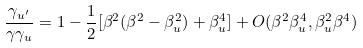Convert formula to latex. <formula><loc_0><loc_0><loc_500><loc_500>\frac { \gamma _ { u ^ { \prime } } } { \gamma \gamma _ { u } } = 1 - \frac { 1 } { 2 } [ \beta ^ { 2 } ( \beta ^ { 2 } - \beta _ { u } ^ { 2 } ) + \beta _ { u } ^ { 4 } ] + O ( \beta ^ { 2 } \beta _ { u } ^ { 4 } , \beta _ { u } ^ { 2 } \beta ^ { 4 } )</formula> 